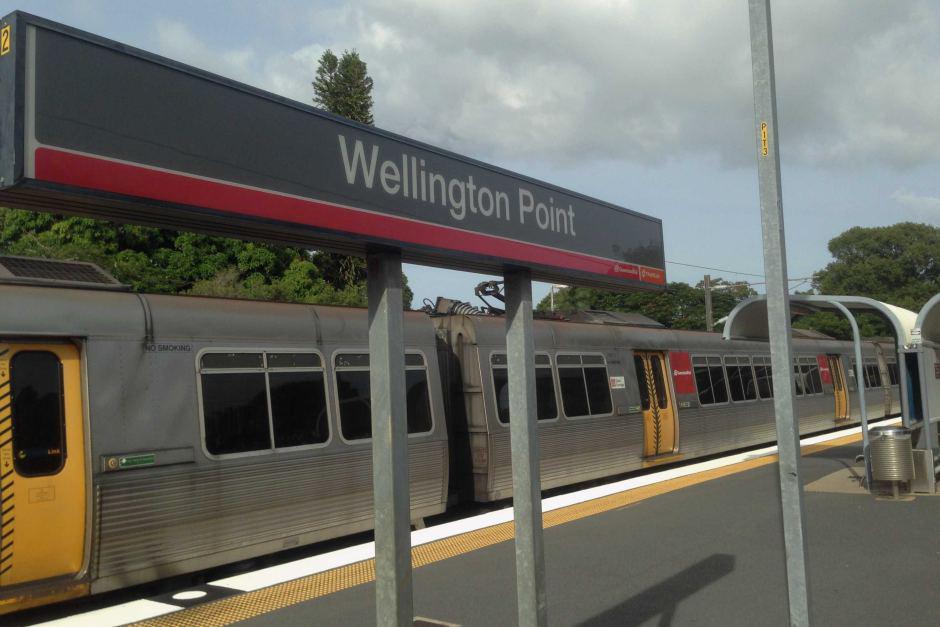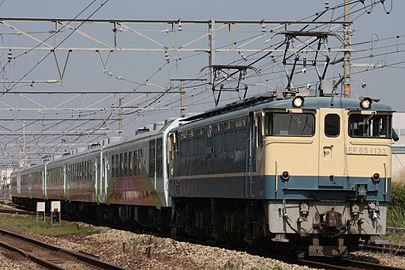The first image is the image on the left, the second image is the image on the right. Assess this claim about the two images: "At least one image shows a green train with red-orange trim pulling a line of freight cars.". Correct or not? Answer yes or no. No. 